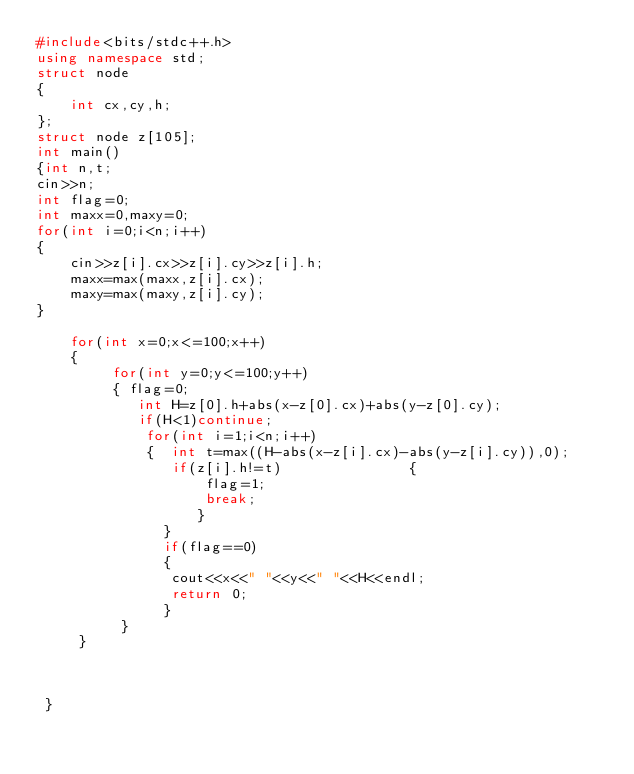Convert code to text. <code><loc_0><loc_0><loc_500><loc_500><_C++_>#include<bits/stdc++.h>
using namespace std;
struct node
{
	int cx,cy,h;
};
struct node z[105];
int main()
{int n,t;
cin>>n;
int flag=0;
int maxx=0,maxy=0;
for(int i=0;i<n;i++)
{
	cin>>z[i].cx>>z[i].cy>>z[i].h;
	maxx=max(maxx,z[i].cx);
	maxy=max(maxy,z[i].cy);
}
 
 	for(int x=0;x<=100;x++)
 	{
 		 for(int y=0;y<=100;y++)
 		 { flag=0;
 		 	int H=z[0].h+abs(x-z[0].cx)+abs(y-z[0].cy);
 		 	if(H<1)continue;
 		 	 for(int i=1;i<n;i++)
 		 	 {  int t=max((H-abs(x-z[i].cx)-abs(y-z[i].cy)),0);
 		 	 	if(z[i].h!=t) 		 	 	{
 		 	 		flag=1;
 		 	 		break;
				   }
			   }
			   if(flag==0)
			   {
			   	cout<<x<<" "<<y<<" "<<H<<endl;
			   	return 0;
			   }
		  }
	 }
 


 } </code> 